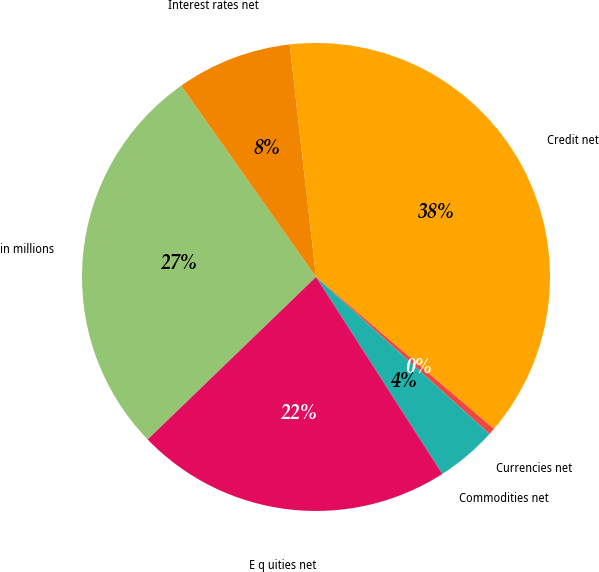Convert chart to OTSL. <chart><loc_0><loc_0><loc_500><loc_500><pie_chart><fcel>in millions<fcel>Interest rates net<fcel>Credit net<fcel>Currencies net<fcel>Commodities net<fcel>E q uities net<nl><fcel>27.45%<fcel>7.98%<fcel>38.04%<fcel>0.46%<fcel>4.22%<fcel>21.85%<nl></chart> 